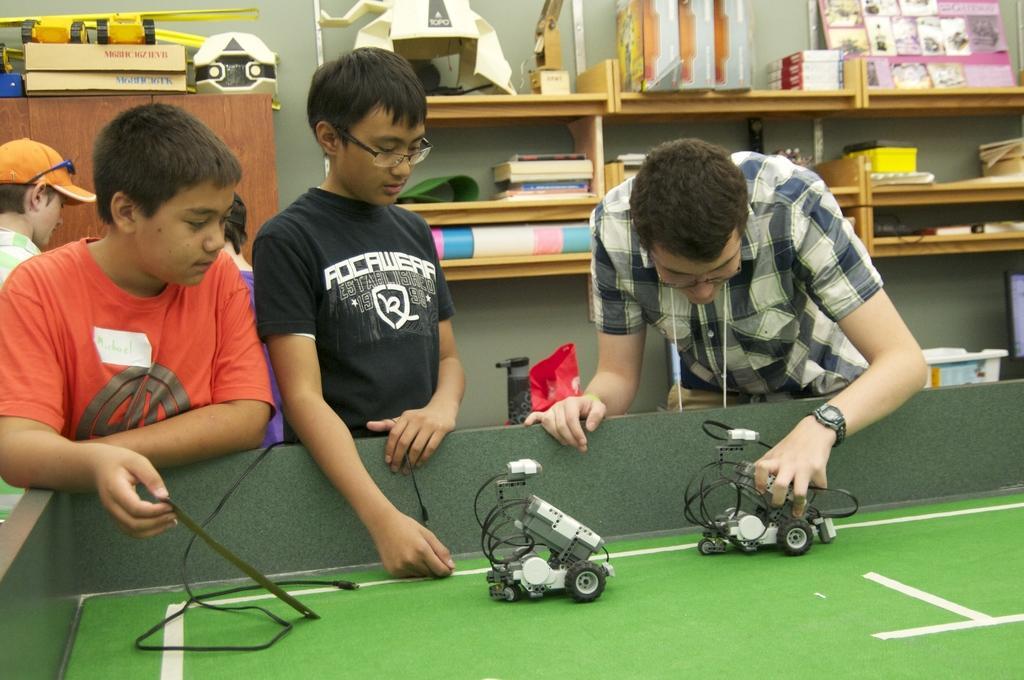Could you give a brief overview of what you see in this image? In this image I see 2 boys and a man over here and I see a table on which there are 2 toys and I see the wire over here. In the background I see the racks on which there are many things and I see few more things over here. 